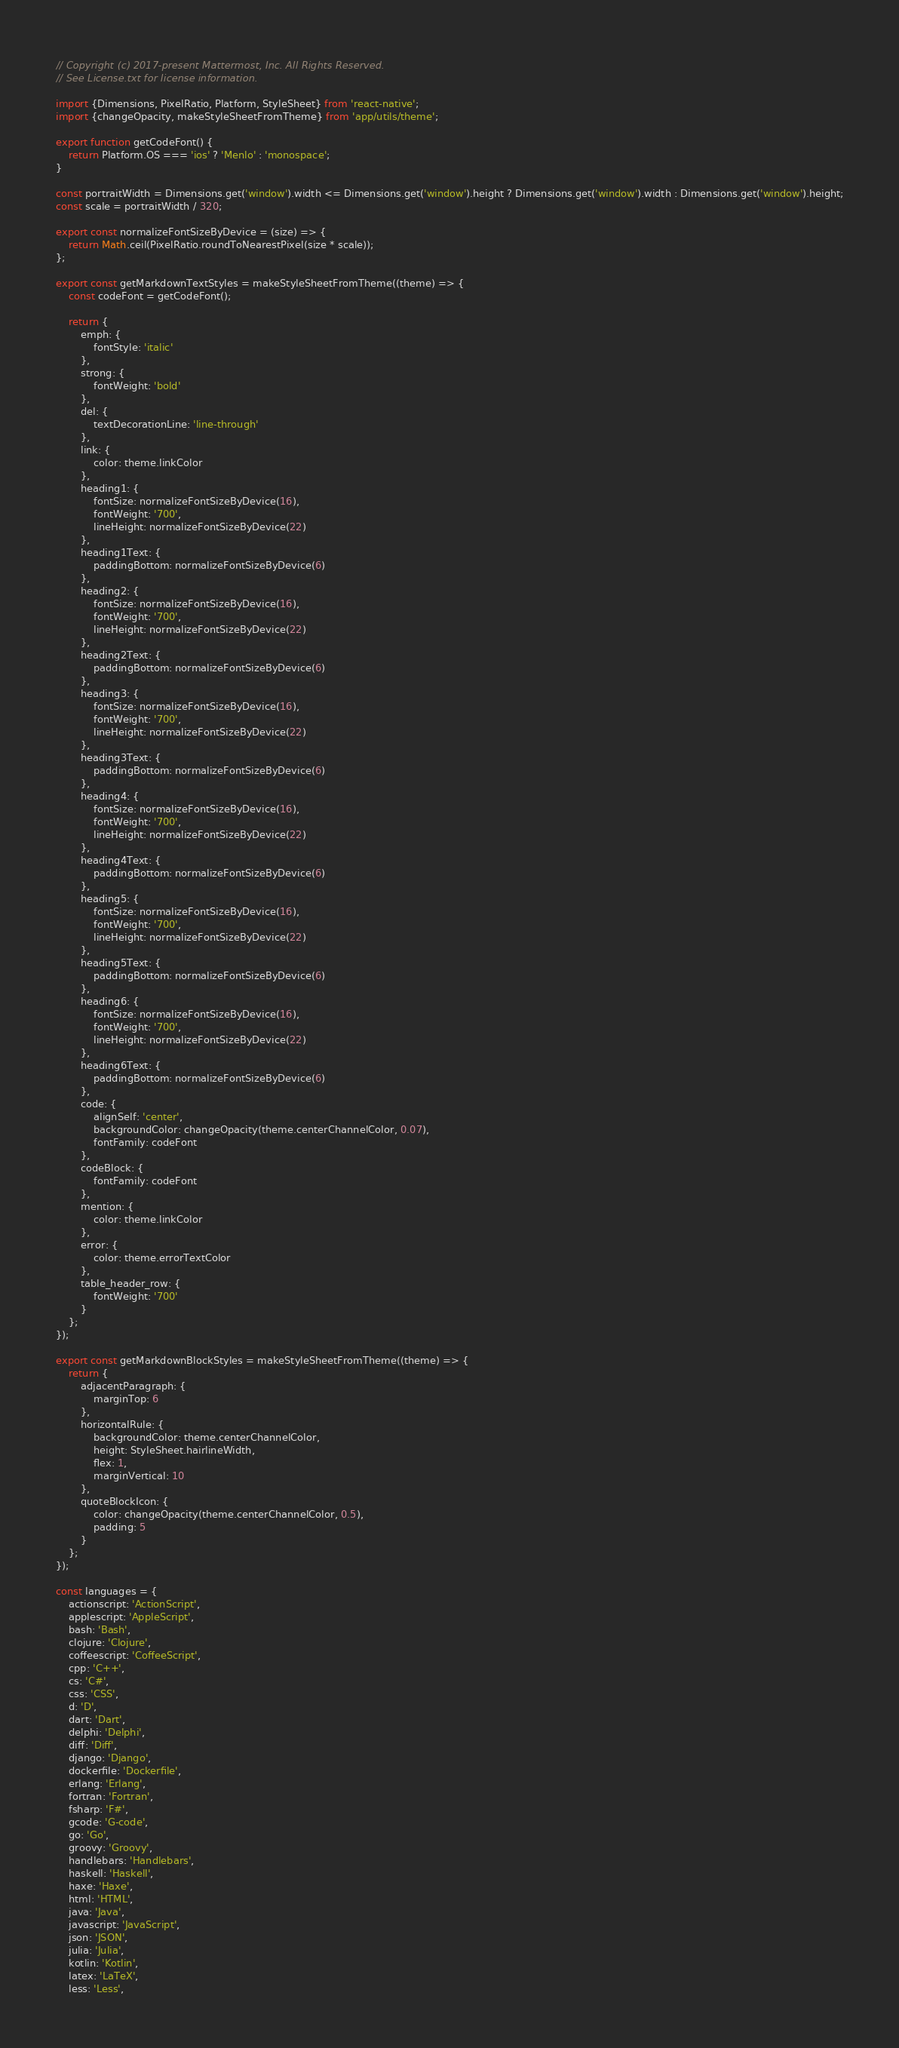Convert code to text. <code><loc_0><loc_0><loc_500><loc_500><_JavaScript_>// Copyright (c) 2017-present Mattermost, Inc. All Rights Reserved.
// See License.txt for license information.

import {Dimensions, PixelRatio, Platform, StyleSheet} from 'react-native';
import {changeOpacity, makeStyleSheetFromTheme} from 'app/utils/theme';

export function getCodeFont() {
    return Platform.OS === 'ios' ? 'Menlo' : 'monospace';
}

const portraitWidth = Dimensions.get('window').width <= Dimensions.get('window').height ? Dimensions.get('window').width : Dimensions.get('window').height;
const scale = portraitWidth / 320;

export const normalizeFontSizeByDevice = (size) => {
    return Math.ceil(PixelRatio.roundToNearestPixel(size * scale));
};

export const getMarkdownTextStyles = makeStyleSheetFromTheme((theme) => {
    const codeFont = getCodeFont();

    return {
        emph: {
            fontStyle: 'italic'
        },
        strong: {
            fontWeight: 'bold'
        },
        del: {
            textDecorationLine: 'line-through'
        },
        link: {
            color: theme.linkColor
        },
        heading1: {
            fontSize: normalizeFontSizeByDevice(16),
            fontWeight: '700',
            lineHeight: normalizeFontSizeByDevice(22)
        },
        heading1Text: {
            paddingBottom: normalizeFontSizeByDevice(6)
        },
        heading2: {
            fontSize: normalizeFontSizeByDevice(16),
            fontWeight: '700',
            lineHeight: normalizeFontSizeByDevice(22)
        },
        heading2Text: {
            paddingBottom: normalizeFontSizeByDevice(6)
        },
        heading3: {
            fontSize: normalizeFontSizeByDevice(16),
            fontWeight: '700',
            lineHeight: normalizeFontSizeByDevice(22)
        },
        heading3Text: {
            paddingBottom: normalizeFontSizeByDevice(6)
        },
        heading4: {
            fontSize: normalizeFontSizeByDevice(16),
            fontWeight: '700',
            lineHeight: normalizeFontSizeByDevice(22)
        },
        heading4Text: {
            paddingBottom: normalizeFontSizeByDevice(6)
        },
        heading5: {
            fontSize: normalizeFontSizeByDevice(16),
            fontWeight: '700',
            lineHeight: normalizeFontSizeByDevice(22)
        },
        heading5Text: {
            paddingBottom: normalizeFontSizeByDevice(6)
        },
        heading6: {
            fontSize: normalizeFontSizeByDevice(16),
            fontWeight: '700',
            lineHeight: normalizeFontSizeByDevice(22)
        },
        heading6Text: {
            paddingBottom: normalizeFontSizeByDevice(6)
        },
        code: {
            alignSelf: 'center',
            backgroundColor: changeOpacity(theme.centerChannelColor, 0.07),
            fontFamily: codeFont
        },
        codeBlock: {
            fontFamily: codeFont
        },
        mention: {
            color: theme.linkColor
        },
        error: {
            color: theme.errorTextColor
        },
        table_header_row: {
            fontWeight: '700'
        }
    };
});

export const getMarkdownBlockStyles = makeStyleSheetFromTheme((theme) => {
    return {
        adjacentParagraph: {
            marginTop: 6
        },
        horizontalRule: {
            backgroundColor: theme.centerChannelColor,
            height: StyleSheet.hairlineWidth,
            flex: 1,
            marginVertical: 10
        },
        quoteBlockIcon: {
            color: changeOpacity(theme.centerChannelColor, 0.5),
            padding: 5
        }
    };
});

const languages = {
    actionscript: 'ActionScript',
    applescript: 'AppleScript',
    bash: 'Bash',
    clojure: 'Clojure',
    coffeescript: 'CoffeeScript',
    cpp: 'C++',
    cs: 'C#',
    css: 'CSS',
    d: 'D',
    dart: 'Dart',
    delphi: 'Delphi',
    diff: 'Diff',
    django: 'Django',
    dockerfile: 'Dockerfile',
    erlang: 'Erlang',
    fortran: 'Fortran',
    fsharp: 'F#',
    gcode: 'G-code',
    go: 'Go',
    groovy: 'Groovy',
    handlebars: 'Handlebars',
    haskell: 'Haskell',
    haxe: 'Haxe',
    html: 'HTML',
    java: 'Java',
    javascript: 'JavaScript',
    json: 'JSON',
    julia: 'Julia',
    kotlin: 'Kotlin',
    latex: 'LaTeX',
    less: 'Less',</code> 